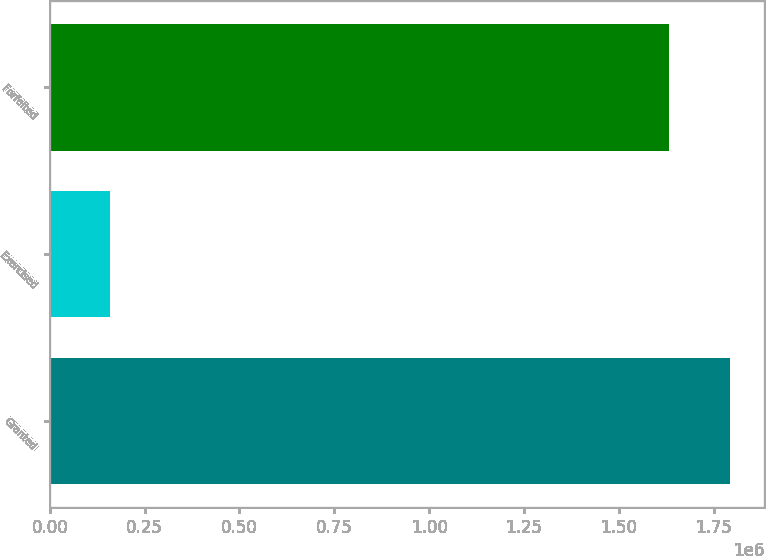<chart> <loc_0><loc_0><loc_500><loc_500><bar_chart><fcel>Granted<fcel>Exercised<fcel>Forfeited<nl><fcel>1.79379e+06<fcel>159521<fcel>1.63161e+06<nl></chart> 